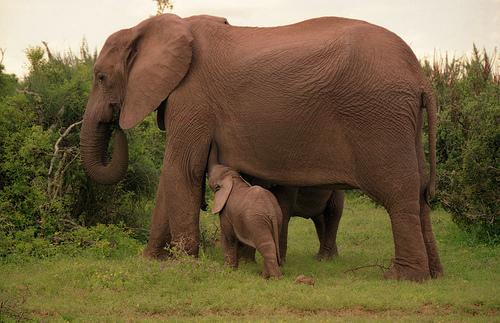Count how many different objects, animals, or other items of interest are mentioned in the image descriptions. There are 19 distinct entities mentioned: baby elephant, mother elephant, trunk, ear, tail, eye, head, leg, bushes, trees, sky, grassy field, branches, rock, broken branch, poop, sunlight, hind leg, and gray sky. Assess the image quality and mention any noticeable flaws. The image quality is decent, but there might be some overlapping of objects or entities detected and some possible misalignment of bounding boxes. Analyze the interactions between two or more subjects in the image. The baby elephant is interacting with its mother by being close to her and reaching with its trunk, which could indicate curiosity, playfulness, or bonding. Provide a short summary of the scene depicted in the image. The image displays a baby elephant and its mother in a grassy outdoor area with trees and bushes, as the baby elephant is reaching with its trunk. What emotions or feelings are evoked by the image? The image evokes feelings of serenity, family bonding, and the beauty of nature. How many elephants are in the image and what are the notable features of each? There are two elephants: a large mother elephant with a big ear and a small baby elephant with a reaching trunk. Perform a complex reasoning task by identifying what is unusual for the scene described. It is unusual to find elephant poop in the image, as it is not a typical element of focus in a scene like this. What is the location of the scene and what type of environment is it? The location is a grassy green field outdoors, possibly a savannah or a park, with short trees and gray sky. Identify the main subjects in the image and their actions. A baby elephant with its trunk up and a large mother elephant are present in the image, surrounded by bushes and trees with a gray sky overhead. Does the small baby elephant have wings and can it fly? This instruction is misleading because it suggests that the baby elephant has an additional feature (wings) that is not presented in the image's information, and it implies that it can perform an action (flying) that is not possible for an elephant. Which object is on the left side of the baby elephant? The large mother elephant is on the left side of the baby elephant. Evaluate the image quality considering clarity, brightness and details. The image quality is good, with clear details, adequate brightness, and a balanced composition. Is the image evoking more positive or negative emotions? The image evokes positive emotions. Is the large female elephant wearing a hat and sunglasses? This instruction is misleading because it adds unexpected and unnatural elements (a hat and sunglasses) to the image, which elephants do not typically wear. These features are not mentioned in the given information about the large female elephant. Does the image contain any text or writing that needs extraction? No, there is no text or writing in the image. What color is the sky in the photo? The sky is yellow dusky sunlight and gray. List the objects and their attributes in the image. baby elephant (reaching with its trunk), mother elephant (large ear, big trunk), grassy outdoor area, leafy bushes, tree branches, elephant poop, yellow dusky sunlight sky, small broken branch, grass patch, gray sky overhead. How many elephants are in the image? There are two elephants in the image. Identify what is the sentiment conveyed by the image. The sentiment is joyful and warm, showing a mother and baby elephant bonding. Where is the pile of elephant poop located in the image? X:293 Y:271 Width:25 Height:25 Are there three little birds sitting on the pile of elephant poop? This instruction is misleading because it adds an element not mentioned in the information provided for the image (birds) and places them on an unlikely location (elephant poop). It leads the reader to believe that there are birds in the image, which may not be true. What type of trees are in the image? There is a stand of short trees in the photo. Is the branch on the ground purple with yellow polka dots? This instruction is misleading because it attributes an unnatural and unlikely color/pattern combination for the branch on the ground, and there is no mention of these colors in the original information provided. Describe the baby elephant's position in relation to the mother elephant. The baby elephant is behind and slightly under its mother. Determine the location of the small broken branch in the image. X:344 Y:253 Width:54 Height:54 Find the X and Y coordinates of the big elephant ear. X:116 Y:13 Is there a rainbow visible in the yellow dusky sunlight sky? This instruction is misleading because it implies a specific weather phenomenon (a rainbow) is present in the sky, which is not mentioned in the image's information. The sky is described as yellow dusky sunlight, not mentioning any rainbows. Describe the relationship between the objects in the image. A mother elephant and her baby are bonding in a grassy outdoor area, surrounded by trees, bushes, and branches. They are interacting with their trunk and tail. Do the green bushes have bright red flowers blooming all over them? This instruction is misleading because it introduces an element (red flowers) that does not exist in the provided information for the image, implying that the bushes have flowers when there may not be any. What are the dimensions of the grassy green field in the image? X:1 Y:187 Width:497 Height:497 